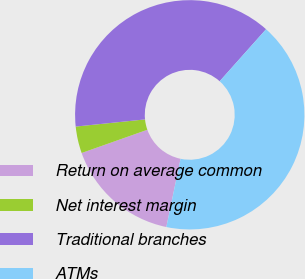Convert chart to OTSL. <chart><loc_0><loc_0><loc_500><loc_500><pie_chart><fcel>Return on average common<fcel>Net interest margin<fcel>Traditional branches<fcel>ATMs<nl><fcel>16.32%<fcel>3.77%<fcel>38.23%<fcel>41.68%<nl></chart> 